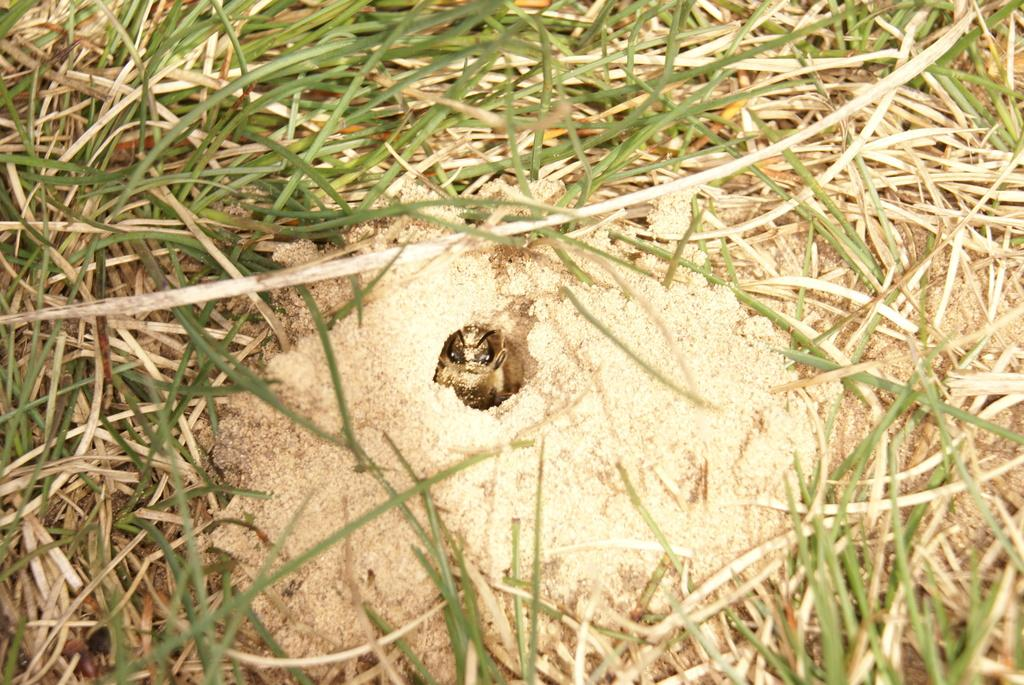What is located in the middle of the image? There is an insect in the middle of the image. What type of vegetation can be seen in the image? There is grass visible in the image. What type of home does the insect live in within the image? There is no indication of a home for the insect in the image. What type of wax can be seen in the image? There is no wax present in the image. 